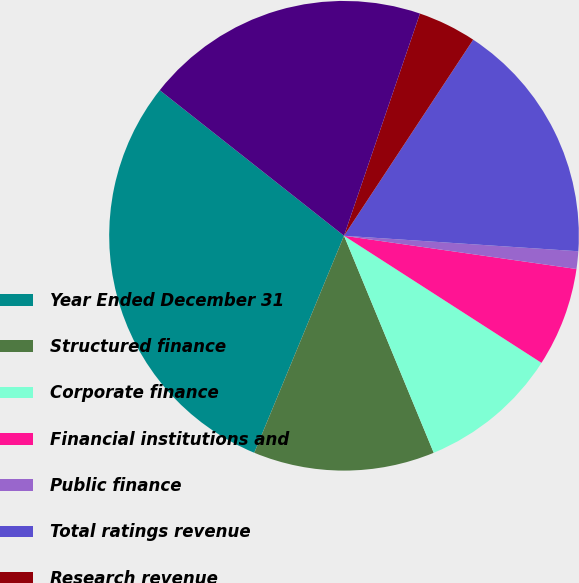Convert chart. <chart><loc_0><loc_0><loc_500><loc_500><pie_chart><fcel>Year Ended December 31<fcel>Structured finance<fcel>Corporate finance<fcel>Financial institutions and<fcel>Public finance<fcel>Total ratings revenue<fcel>Research revenue<fcel>Total Moody's Investors<nl><fcel>29.4%<fcel>12.48%<fcel>9.66%<fcel>6.84%<fcel>1.21%<fcel>16.78%<fcel>4.03%<fcel>19.6%<nl></chart> 